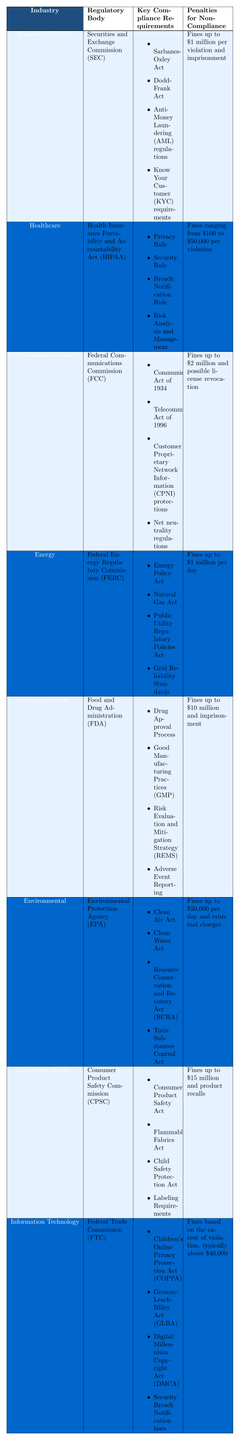What is the regulatory body for the Financial Services industry? The table lists the regulatory body for the Financial Services industry as the Securities and Exchange Commission (SEC).
Answer: Securities and Exchange Commission (SEC) Which industry has penalties for non-compliance of up to $10 million? By reviewing the table, it shows that the Pharmaceutical industry has penalties for non-compliance of up to $10 million and imprisonment.
Answer: Pharmaceutical Are there any industries listed that do not have imprisonment as a penalty for non-compliance? By checking the table, I can see that the Healthcare, Telecommunications, and Environmental industries are among those that do not list imprisonment as a penalty for non-compliance.
Answer: Yes Which industry has the lowest potential fine for non-compliance? Looking through the listed penalties, the Healthcare industry has the lowest potential fine, ranging from $100 to $50,000 per violation.
Answer: Healthcare What is the average penalty for non-compliance across the listed industries? To calculate the average, we need to convert each industry's penalty to a numerical value and then sum them: (1 million for Financial Services + 50,000 for Healthcare + 2 million for Telecommunications + 1 million for Energy + 10 million for Pharmaceutical + 50,000 per day for Environmental + 15 million for Consumer Goods + 40,000 for Information Technology). Note that for Environmental, we can use a sample of 30 days for calculation, resulting in $50,000*30 = $1,500,000. The total is then $1 million + $50,000 + $2 million + $1 million + $10 million + $1.5 million + $15 million + $40,000 = $31,540,000. There are 8 entries, thus, the average is $31,540,000 / 8 = $3,942,500.
Answer: $3,942,500 In how many industries are there specific compliance requirements related to customer privacy? The table shows that there are three relevant industries: Financial Services (Know Your Customer requirements), Healthcare (Privacy Rule), and Information Technology (Children’s Online Privacy Protection Act). That makes it three industries focused on customer privacy compliance.
Answer: Three What comparable compliance requirements do the Telecommunications and Energy industries share? Upon reviewing the table, the Telecommunications and Energy industries both have regulations concerning infrastructure laws; Telecommunications has the Communications Act and the Telecommunications Act, while Energy follows the Energy Policy Act and the Public Utility Regulatory Policies Act. They both focus on operational standards and compliance regimes that ensure infrastructure stability.
Answer: Both focus on infrastructure compliance Is there a correlation between the industry and potential fines? By examining the table, we can see that industries with higher complexities and risks, particularly Pharmaceuticals, Consumer Goods, and Financial Services, tend to have higher penalties, indicating a potential correlation between the nature of the industry and the severity of penalties for non-compliance.
Answer: Yes, there is a correlation 